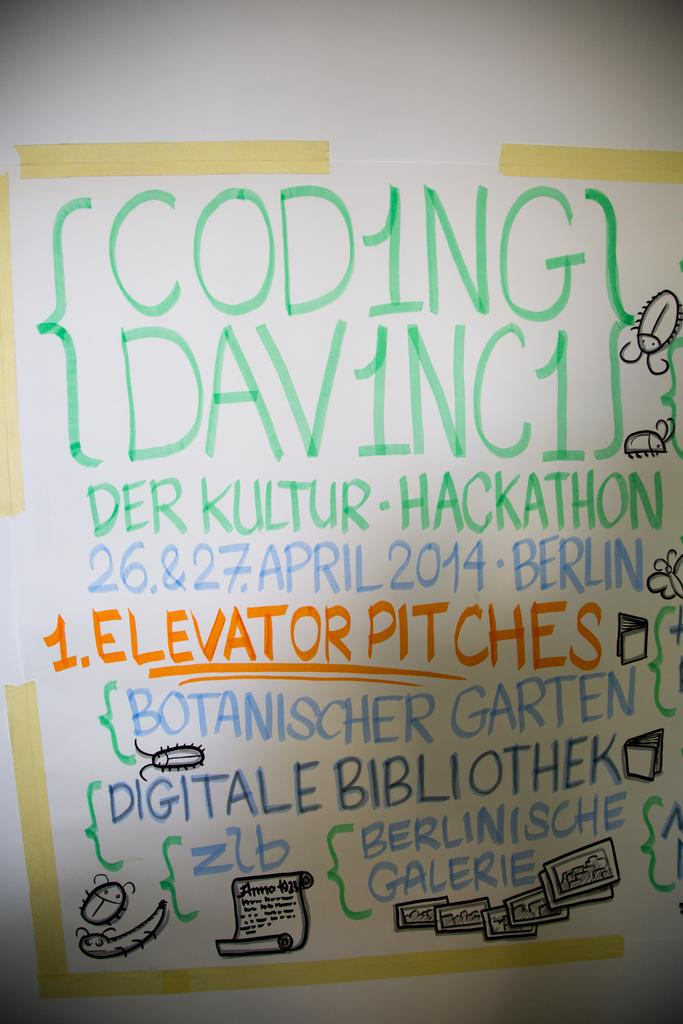<image>
Relay a brief, clear account of the picture shown. A board with different colors and phrases related to codes, libraries and the digital world. 